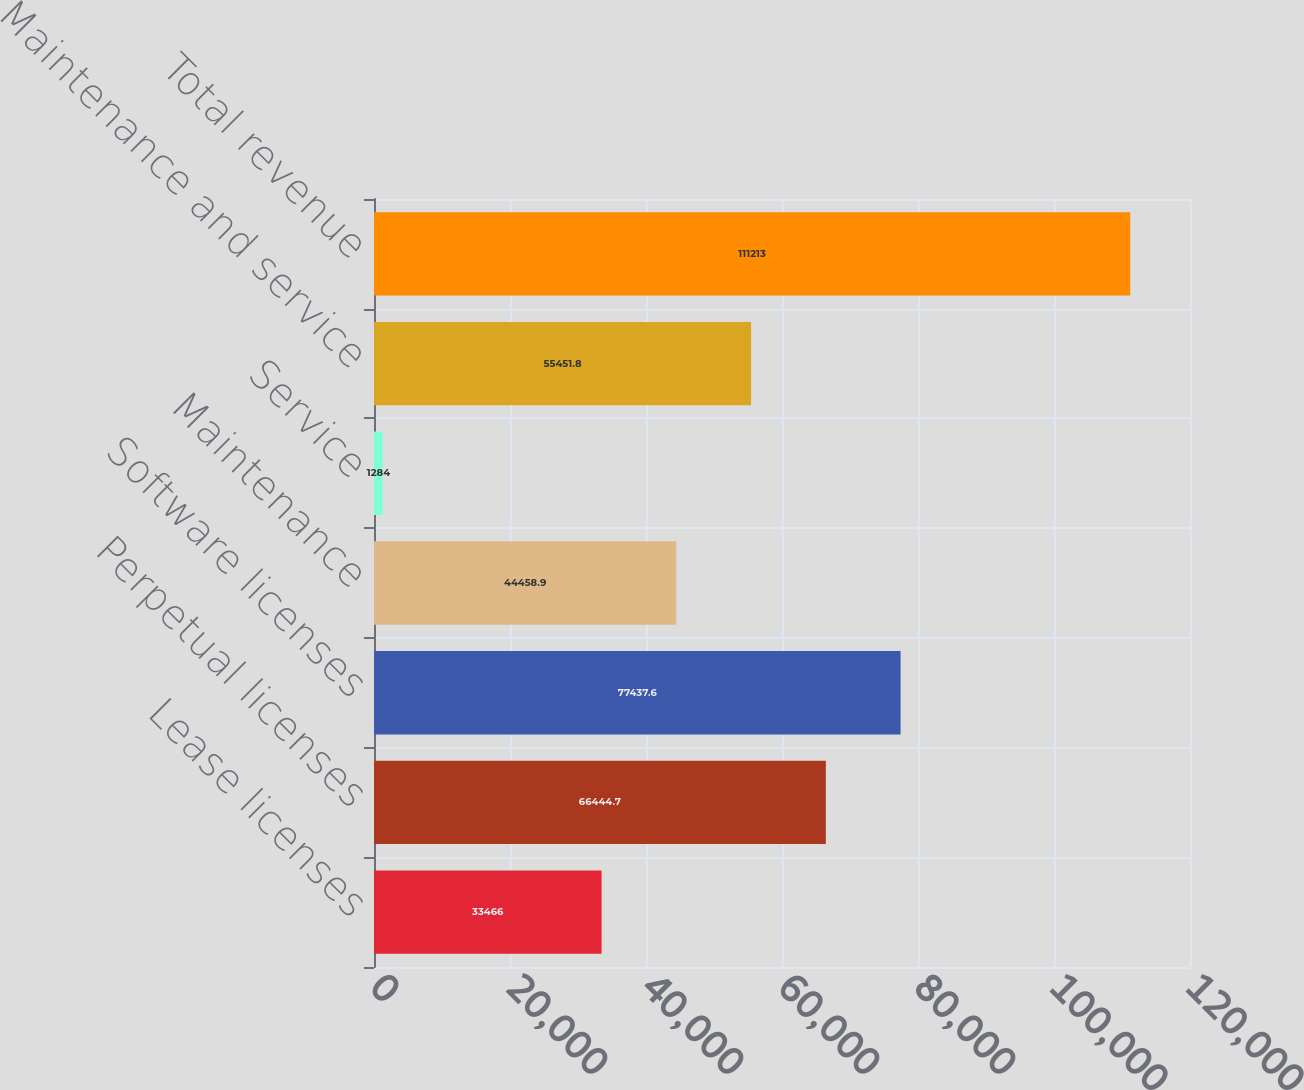Convert chart. <chart><loc_0><loc_0><loc_500><loc_500><bar_chart><fcel>Lease licenses<fcel>Perpetual licenses<fcel>Software licenses<fcel>Maintenance<fcel>Service<fcel>Maintenance and service<fcel>Total revenue<nl><fcel>33466<fcel>66444.7<fcel>77437.6<fcel>44458.9<fcel>1284<fcel>55451.8<fcel>111213<nl></chart> 